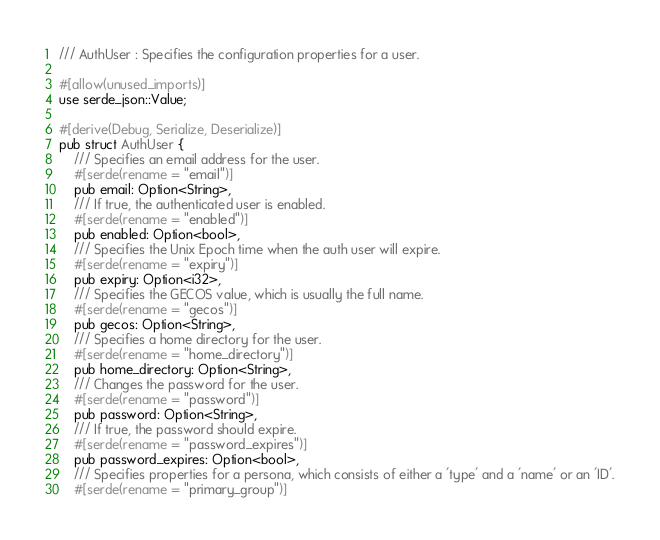Convert code to text. <code><loc_0><loc_0><loc_500><loc_500><_Rust_>/// AuthUser : Specifies the configuration properties for a user.

#[allow(unused_imports)]
use serde_json::Value;

#[derive(Debug, Serialize, Deserialize)]
pub struct AuthUser {
    /// Specifies an email address for the user.
    #[serde(rename = "email")]
    pub email: Option<String>,
    /// If true, the authenticated user is enabled.
    #[serde(rename = "enabled")]
    pub enabled: Option<bool>,
    /// Specifies the Unix Epoch time when the auth user will expire.
    #[serde(rename = "expiry")]
    pub expiry: Option<i32>,
    /// Specifies the GECOS value, which is usually the full name.
    #[serde(rename = "gecos")]
    pub gecos: Option<String>,
    /// Specifies a home directory for the user.
    #[serde(rename = "home_directory")]
    pub home_directory: Option<String>,
    /// Changes the password for the user.
    #[serde(rename = "password")]
    pub password: Option<String>,
    /// If true, the password should expire.
    #[serde(rename = "password_expires")]
    pub password_expires: Option<bool>,
    /// Specifies properties for a persona, which consists of either a 'type' and a 'name' or an 'ID'.
    #[serde(rename = "primary_group")]</code> 